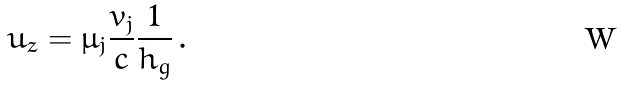<formula> <loc_0><loc_0><loc_500><loc_500>u _ { z } = \mu _ { j } \frac { v _ { j } } { c } \frac { 1 } { h _ { g } } \, .</formula> 